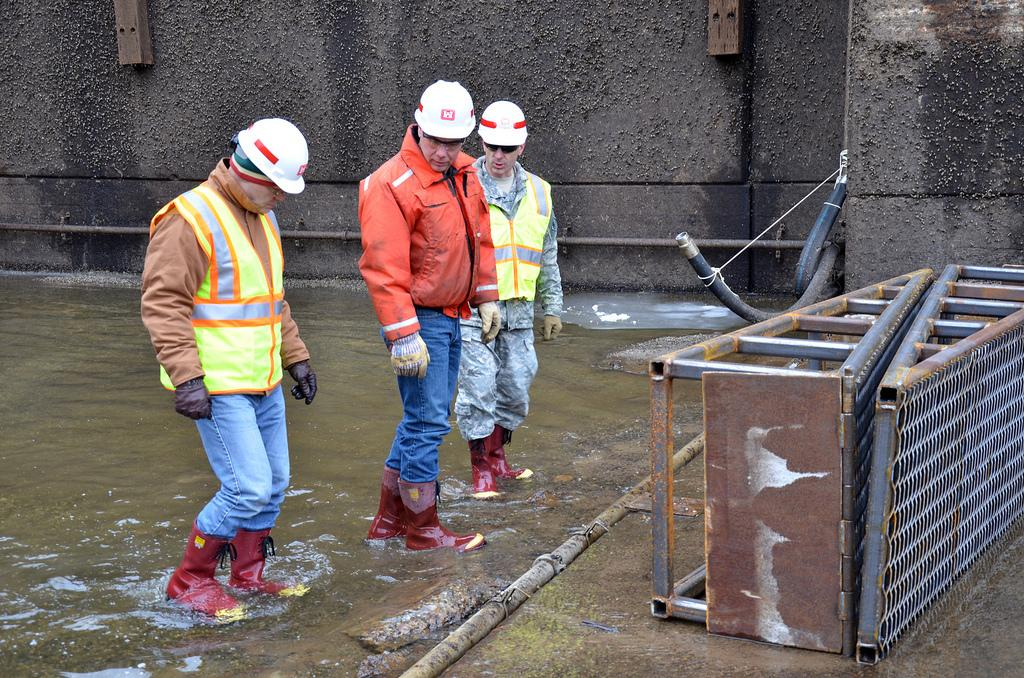How many people are in the image? There is a group of people in the image. What are the people doing in the image? The people are standing in the water. What protective gear are the people wearing? The people are wearing helmets. What type of objects can be seen in the image besides the people? There are metal rods and pipes visible in the image. Can you tell me how many parents are in the image? There is no mention of parents in the image; it only shows a group of people standing in the water. Is there a frog visible in the image? There is no frog present in the image. 